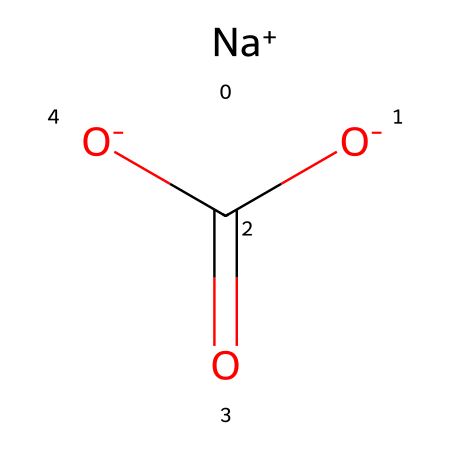What is the chemical name of this compound? The SMILES notation corresponds to sodium bicarbonate, which is a base often used in cooking and as a leavening agent.
Answer: sodium bicarbonate How many atoms are in this molecule? To find the total number of atoms, count each type present: 1 sodium (Na), 1 carbon (C), 3 oxygen (O), and 1 hydrogen (H), totaling 6 atoms.
Answer: 6 How many oxygen atoms are in sodium bicarbonate? The chemical structure has 3 oxygen atoms connected to the carbon atom and involved in its bicarbonate functionality.
Answer: 3 What charge does the sodium ion have? The notation shows sodium as [Na+], indicating it has a positive charge of +1.
Answer: +1 Is sodium bicarbonate an acid or a base? The bicarbonate ion has properties characteristic of a base, as it can accept protons, which defines it as a weak base.
Answer: base What functional group is present in sodium bicarbonate? The presence of a carboxylate group (-COO-) attached to the sodium indicates that it contains a carboxylate functional group.
Answer: carboxylate Can sodium bicarbonate neutralize an acid? Yes, as a base, sodium bicarbonate can react with acids to neutralize them, forming carbon dioxide, water, and a salt in the process.
Answer: yes 